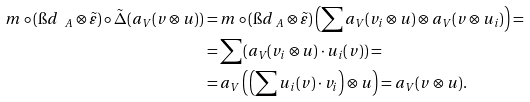<formula> <loc_0><loc_0><loc_500><loc_500>m \circ ( \i d _ { \ A } \otimes \tilde { \varepsilon } ) \circ \tilde { \Delta } ( a _ { V } ( v \otimes u ) ) & = m \circ ( \i d _ { \ A } \otimes \tilde { \varepsilon } ) \left ( \sum a _ { V } ( v _ { i } \otimes u ) \otimes a _ { V } ( v \otimes u _ { i } ) \right ) = \\ & = \sum ( a _ { V } ( v _ { i } \otimes u ) \cdot u _ { i } ( v ) ) = \\ & = a _ { V } \left ( \left ( \sum u _ { i } ( v ) \cdot v _ { i } \right ) \otimes u \right ) = a _ { V } ( v \otimes u ) .</formula> 